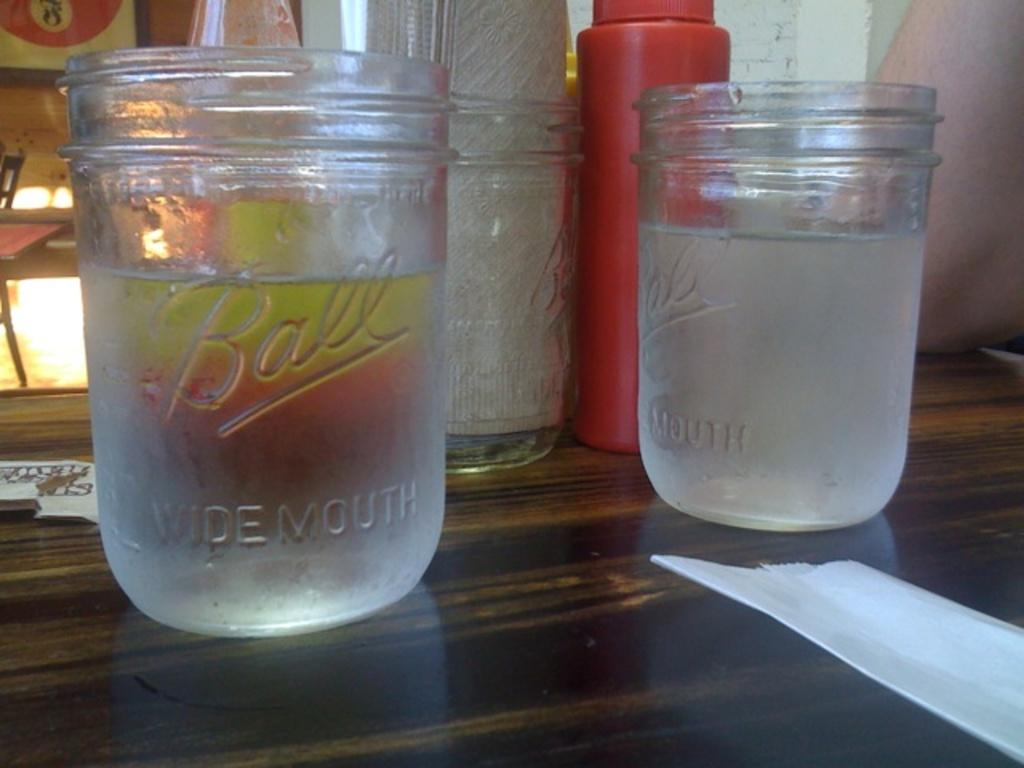What is inside the glass that is visible in the image? There is a glass with liquid in the image. What else can be seen in the image besides the glass? There are bottles and tissues visible in the image. What type of surface is visible in the image? The wooden surface is visible in the image. What can be seen in the background of the image? There is a human body, a wall, and a frame in the background of the image. How many balls are being juggled by the human body in the image? There are no balls visible in the image, and the human body is not performing any actions such as juggling. 